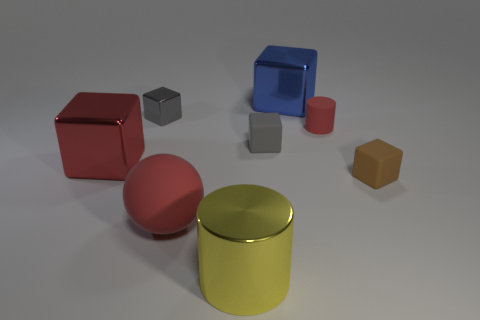Subtract 1 blocks. How many blocks are left? 4 Subtract all large blue metallic cubes. How many cubes are left? 4 Subtract all brown cubes. How many cubes are left? 4 Subtract all yellow blocks. Subtract all purple spheres. How many blocks are left? 5 Add 1 tiny red metallic spheres. How many objects exist? 9 Subtract all balls. How many objects are left? 7 Subtract 0 green cylinders. How many objects are left? 8 Subtract all small cylinders. Subtract all metal cylinders. How many objects are left? 6 Add 1 large red objects. How many large red objects are left? 3 Add 4 brown matte things. How many brown matte things exist? 5 